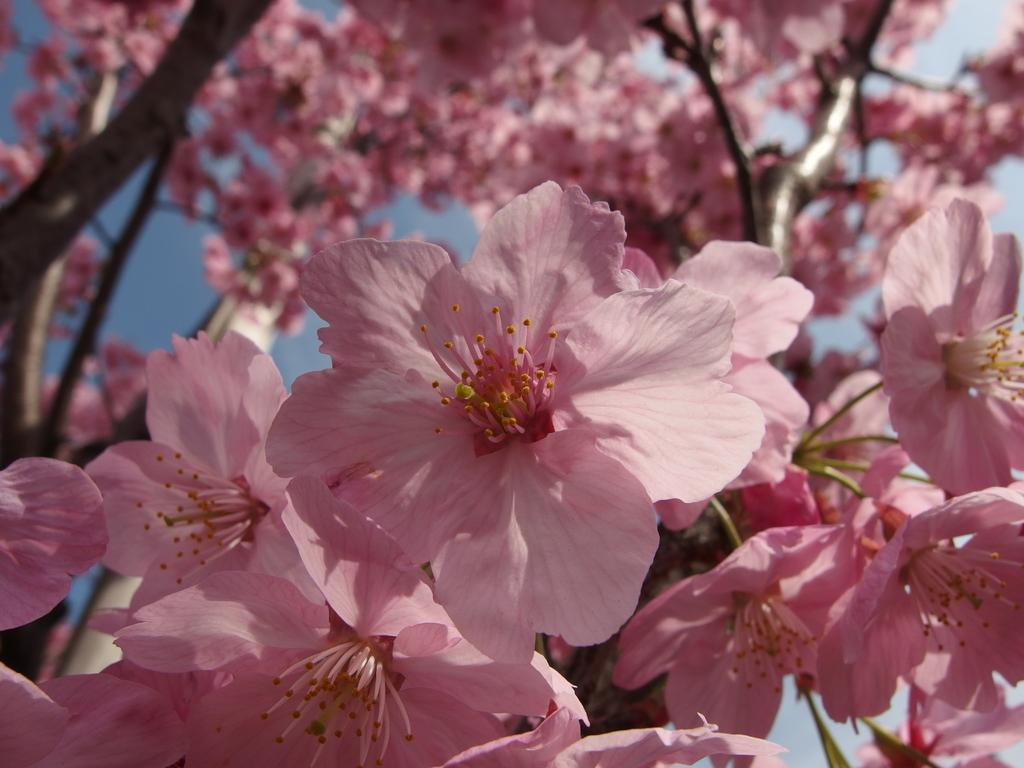What type of living organisms can be seen in the image? Plants can be seen in the image. What specific feature of the plants is visible? The plants have flowers. What color are the flowers? The flowers are pink in color. What type of thing is causing the sleet in the image? There is no sleet present in the image, as it features plants with pink flowers. 